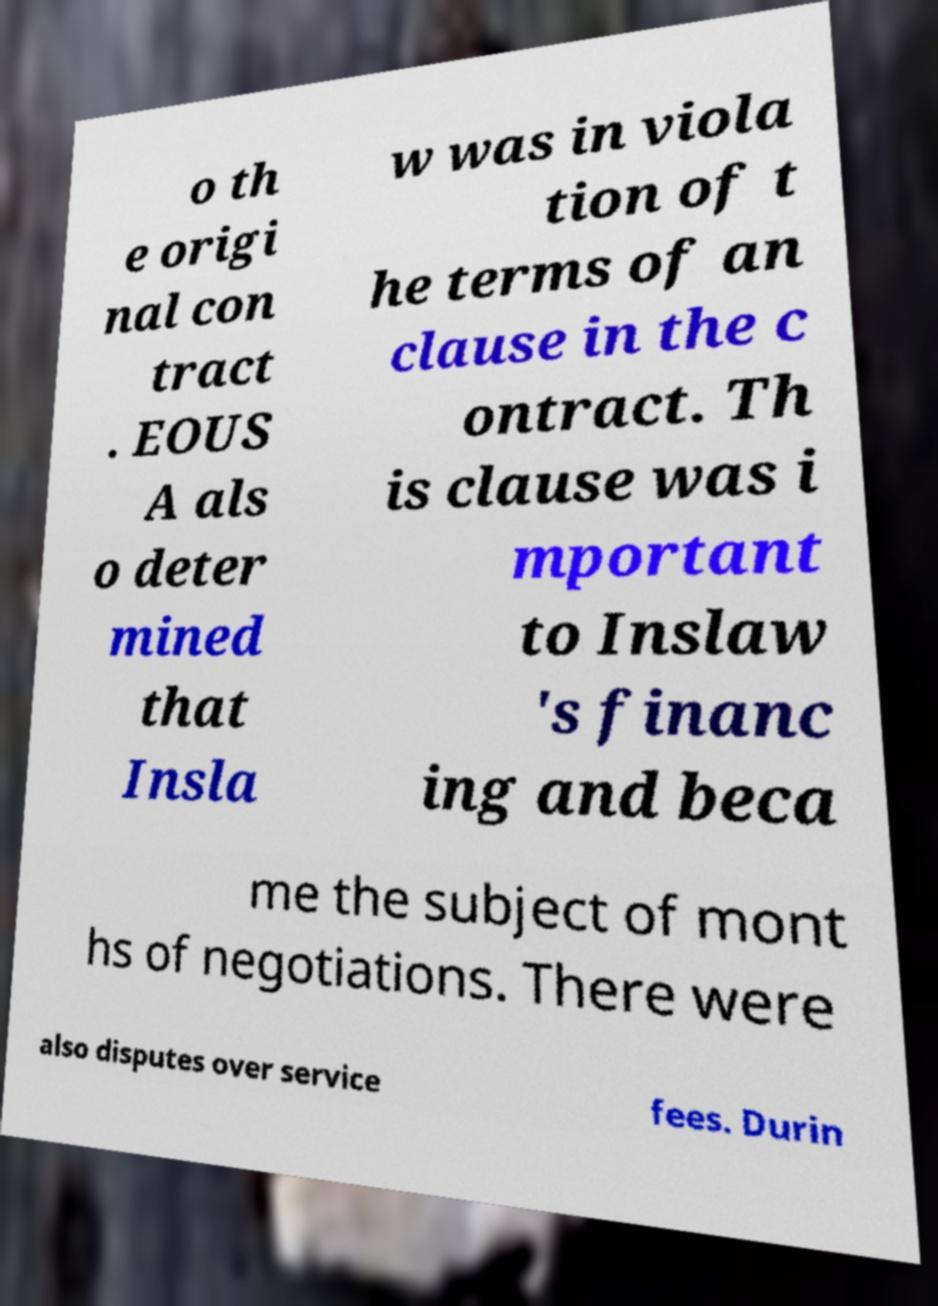Please identify and transcribe the text found in this image. o th e origi nal con tract . EOUS A als o deter mined that Insla w was in viola tion of t he terms of an clause in the c ontract. Th is clause was i mportant to Inslaw 's financ ing and beca me the subject of mont hs of negotiations. There were also disputes over service fees. Durin 